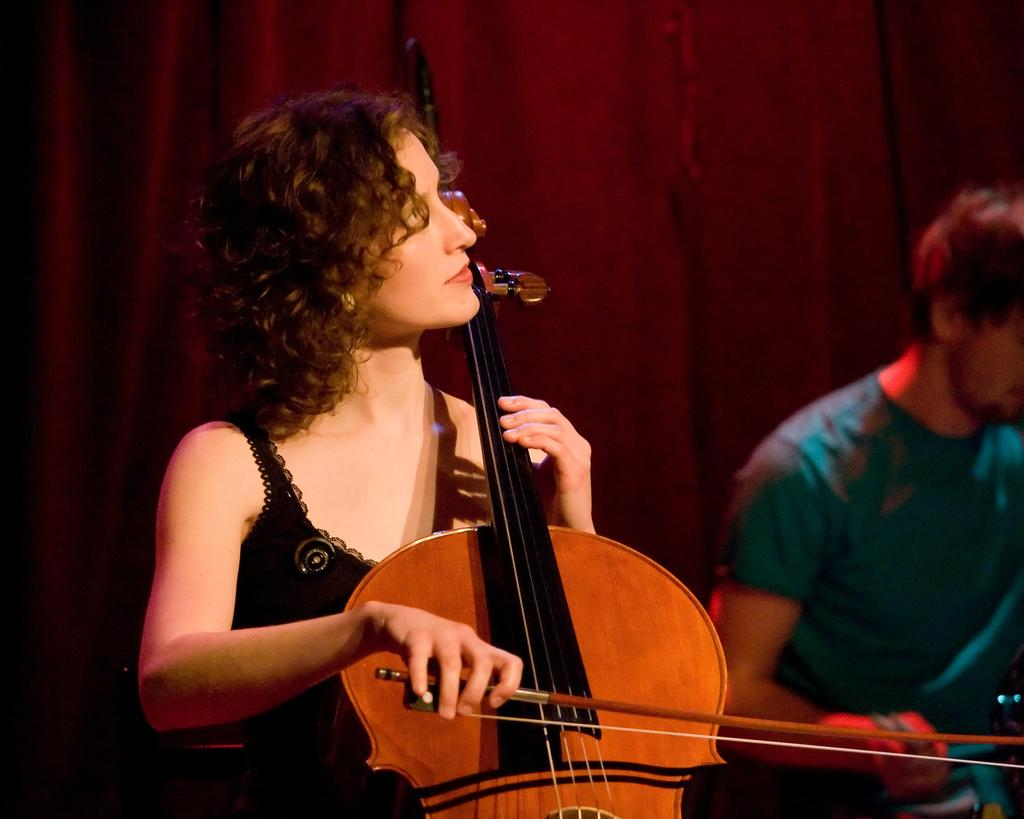How many people are in the image? There are two people in the image. What is the woman doing in the image? The woman is playing the violin. What color is the dress the woman is wearing? The woman is wearing a black dress. Where is the woman located in the image? The woman is in the left corner of the image. What is the man doing in the image? The man is sitting. What color is the t-shirt the man is wearing? The man is wearing a blue t-shirt. What can be seen in the background of the image? There is a red curtain in the background. What type of quince is being used as a prop in the image? There is no quince present in the image. What type of skirt is the woman wearing in the image? The woman is wearing a dress, not a skirt, in the image. 